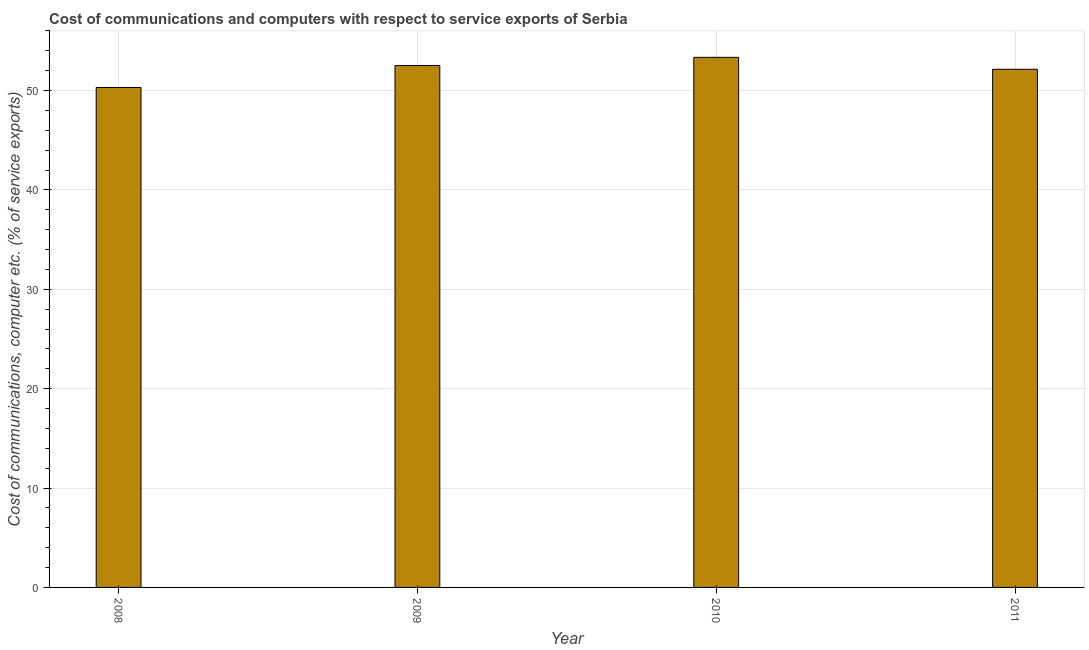What is the title of the graph?
Your answer should be very brief. Cost of communications and computers with respect to service exports of Serbia. What is the label or title of the Y-axis?
Keep it short and to the point. Cost of communications, computer etc. (% of service exports). What is the cost of communications and computer in 2008?
Offer a very short reply. 50.3. Across all years, what is the maximum cost of communications and computer?
Make the answer very short. 53.34. Across all years, what is the minimum cost of communications and computer?
Offer a very short reply. 50.3. In which year was the cost of communications and computer maximum?
Make the answer very short. 2010. What is the sum of the cost of communications and computer?
Offer a terse response. 208.29. What is the difference between the cost of communications and computer in 2008 and 2009?
Keep it short and to the point. -2.21. What is the average cost of communications and computer per year?
Make the answer very short. 52.07. What is the median cost of communications and computer?
Keep it short and to the point. 52.32. In how many years, is the cost of communications and computer greater than 50 %?
Offer a terse response. 4. What is the ratio of the cost of communications and computer in 2009 to that in 2011?
Provide a succinct answer. 1.01. What is the difference between the highest and the second highest cost of communications and computer?
Your answer should be compact. 0.83. What is the difference between the highest and the lowest cost of communications and computer?
Your answer should be very brief. 3.03. In how many years, is the cost of communications and computer greater than the average cost of communications and computer taken over all years?
Ensure brevity in your answer.  3. How many bars are there?
Your answer should be very brief. 4. Are all the bars in the graph horizontal?
Provide a short and direct response. No. What is the Cost of communications, computer etc. (% of service exports) of 2008?
Offer a very short reply. 50.3. What is the Cost of communications, computer etc. (% of service exports) in 2009?
Ensure brevity in your answer.  52.51. What is the Cost of communications, computer etc. (% of service exports) of 2010?
Your response must be concise. 53.34. What is the Cost of communications, computer etc. (% of service exports) of 2011?
Your answer should be very brief. 52.14. What is the difference between the Cost of communications, computer etc. (% of service exports) in 2008 and 2009?
Your answer should be very brief. -2.21. What is the difference between the Cost of communications, computer etc. (% of service exports) in 2008 and 2010?
Make the answer very short. -3.03. What is the difference between the Cost of communications, computer etc. (% of service exports) in 2008 and 2011?
Make the answer very short. -1.83. What is the difference between the Cost of communications, computer etc. (% of service exports) in 2009 and 2010?
Keep it short and to the point. -0.83. What is the difference between the Cost of communications, computer etc. (% of service exports) in 2009 and 2011?
Give a very brief answer. 0.38. What is the difference between the Cost of communications, computer etc. (% of service exports) in 2010 and 2011?
Keep it short and to the point. 1.2. What is the ratio of the Cost of communications, computer etc. (% of service exports) in 2008 to that in 2009?
Ensure brevity in your answer.  0.96. What is the ratio of the Cost of communications, computer etc. (% of service exports) in 2008 to that in 2010?
Ensure brevity in your answer.  0.94. What is the ratio of the Cost of communications, computer etc. (% of service exports) in 2008 to that in 2011?
Your response must be concise. 0.96. What is the ratio of the Cost of communications, computer etc. (% of service exports) in 2009 to that in 2010?
Provide a succinct answer. 0.98. What is the ratio of the Cost of communications, computer etc. (% of service exports) in 2009 to that in 2011?
Provide a succinct answer. 1.01. What is the ratio of the Cost of communications, computer etc. (% of service exports) in 2010 to that in 2011?
Keep it short and to the point. 1.02. 